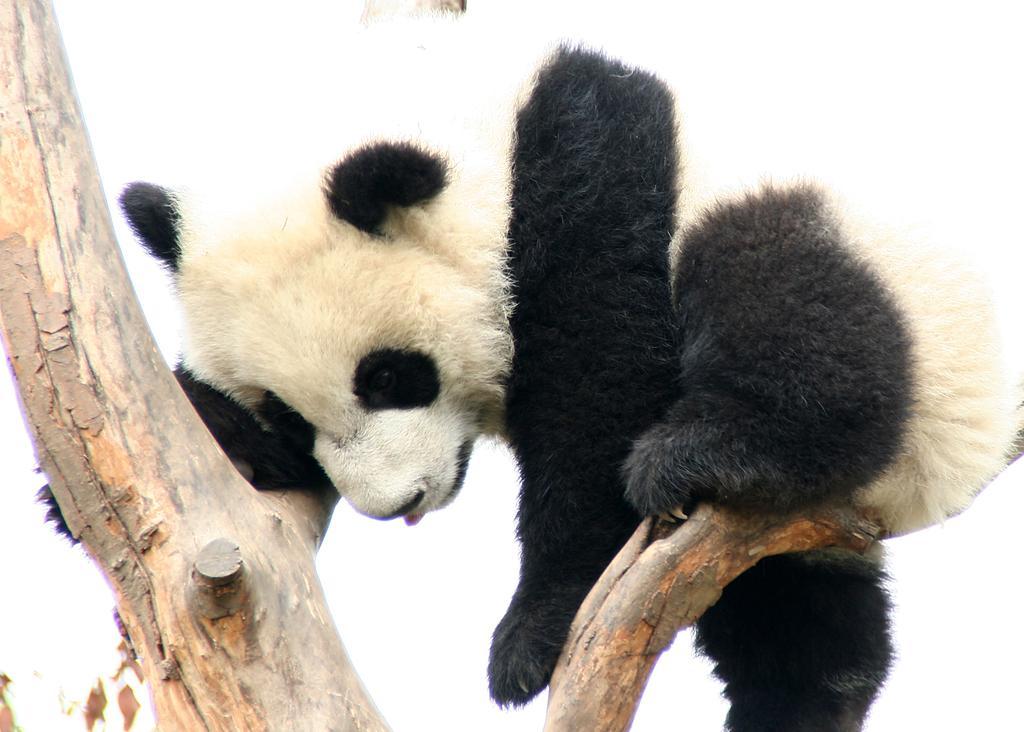Please provide a concise description of this image. In this image I can see a panda which is in white and black color. It is on the branch. Background is in white color. 